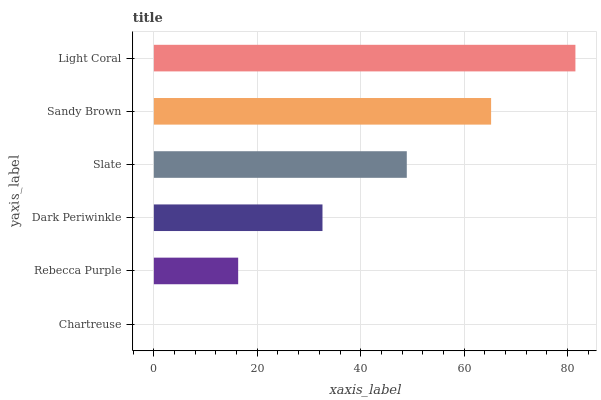Is Chartreuse the minimum?
Answer yes or no. Yes. Is Light Coral the maximum?
Answer yes or no. Yes. Is Rebecca Purple the minimum?
Answer yes or no. No. Is Rebecca Purple the maximum?
Answer yes or no. No. Is Rebecca Purple greater than Chartreuse?
Answer yes or no. Yes. Is Chartreuse less than Rebecca Purple?
Answer yes or no. Yes. Is Chartreuse greater than Rebecca Purple?
Answer yes or no. No. Is Rebecca Purple less than Chartreuse?
Answer yes or no. No. Is Slate the high median?
Answer yes or no. Yes. Is Dark Periwinkle the low median?
Answer yes or no. Yes. Is Light Coral the high median?
Answer yes or no. No. Is Slate the low median?
Answer yes or no. No. 